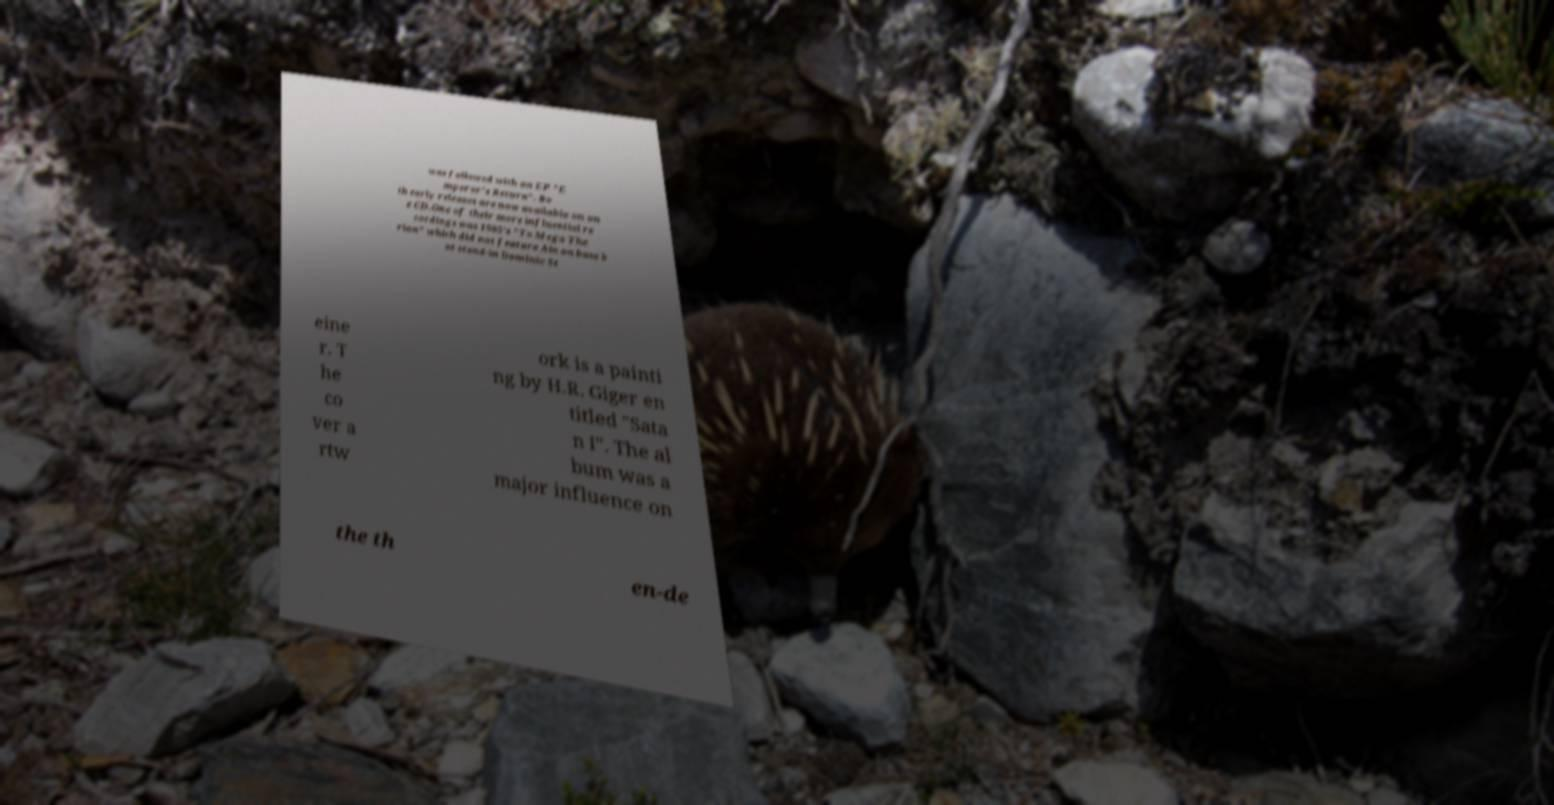There's text embedded in this image that I need extracted. Can you transcribe it verbatim? was followed with an EP "E mperor's Return". Bo th early releases are now available on on e CD.One of their more influential re cordings was 1985's "To Mega The rion" which did not feature Ain on bass b ut stand-in Dominic St eine r. T he co ver a rtw ork is a painti ng by H.R. Giger en titled "Sata n I". The al bum was a major influence on the th en-de 